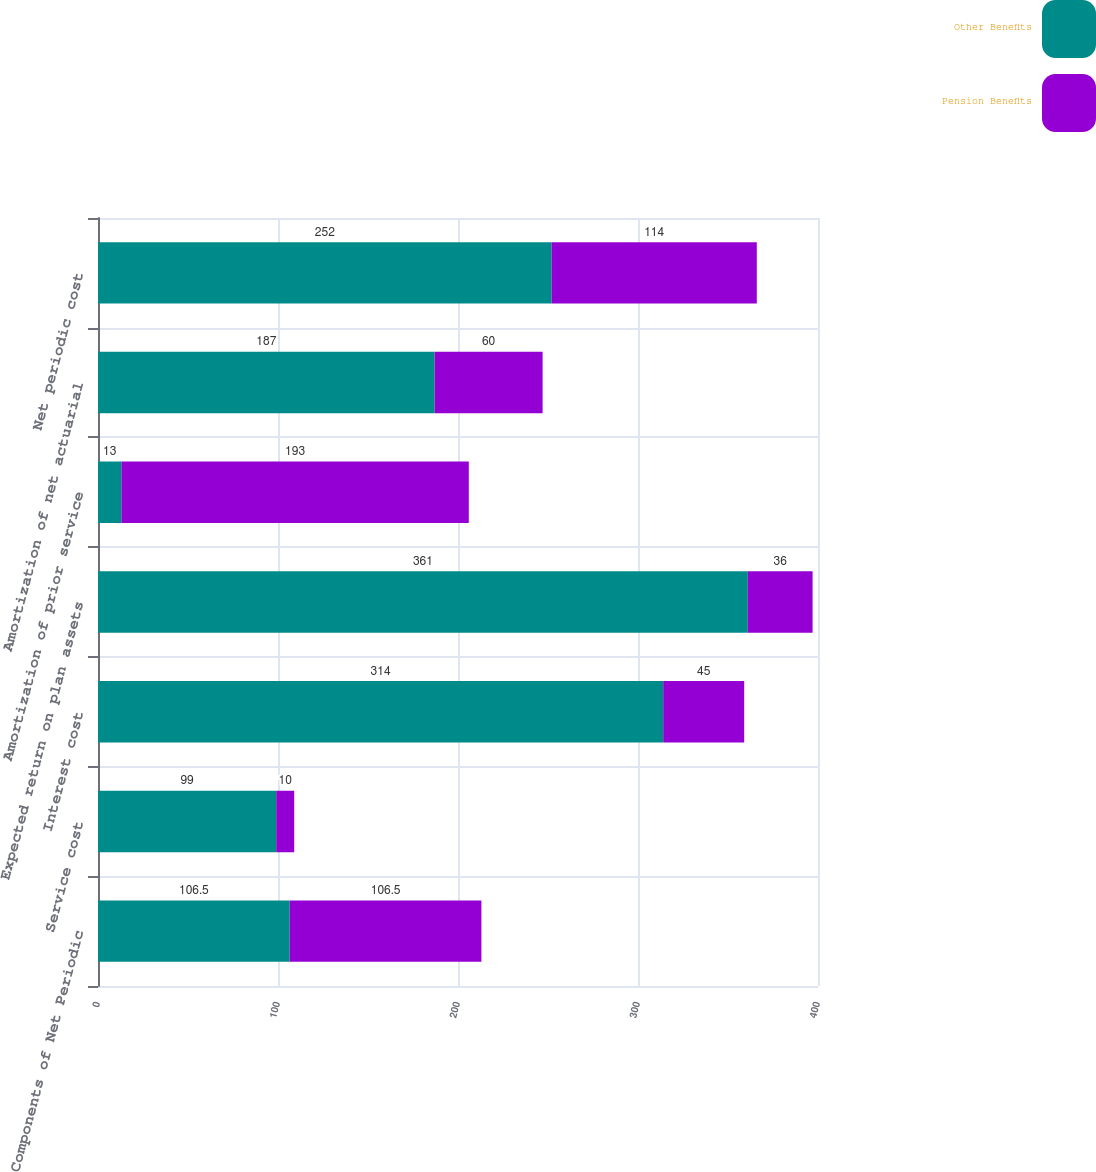Convert chart to OTSL. <chart><loc_0><loc_0><loc_500><loc_500><stacked_bar_chart><ecel><fcel>Components of Net Periodic<fcel>Service cost<fcel>Interest cost<fcel>Expected return on plan assets<fcel>Amortization of prior service<fcel>Amortization of net actuarial<fcel>Net periodic cost<nl><fcel>Other Benefits<fcel>106.5<fcel>99<fcel>314<fcel>361<fcel>13<fcel>187<fcel>252<nl><fcel>Pension Benefits<fcel>106.5<fcel>10<fcel>45<fcel>36<fcel>193<fcel>60<fcel>114<nl></chart> 